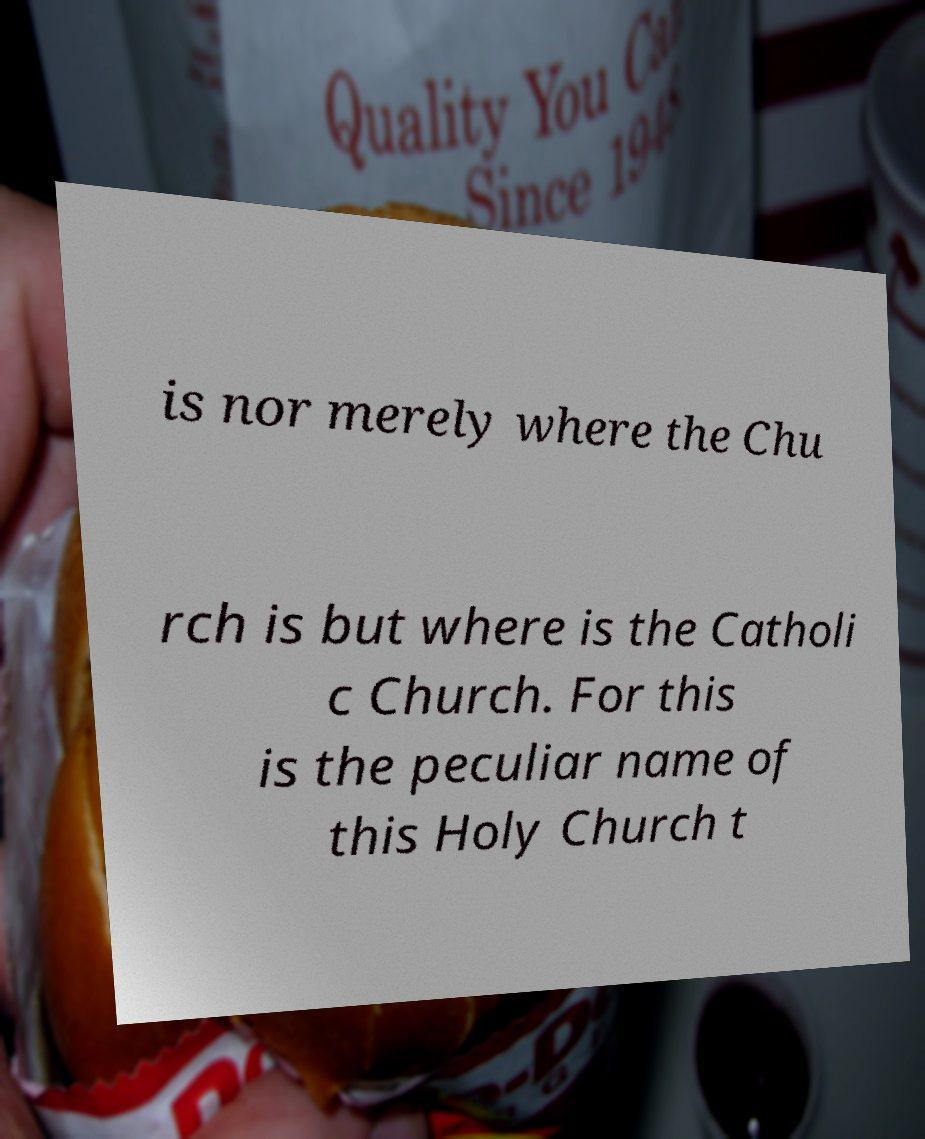For documentation purposes, I need the text within this image transcribed. Could you provide that? is nor merely where the Chu rch is but where is the Catholi c Church. For this is the peculiar name of this Holy Church t 